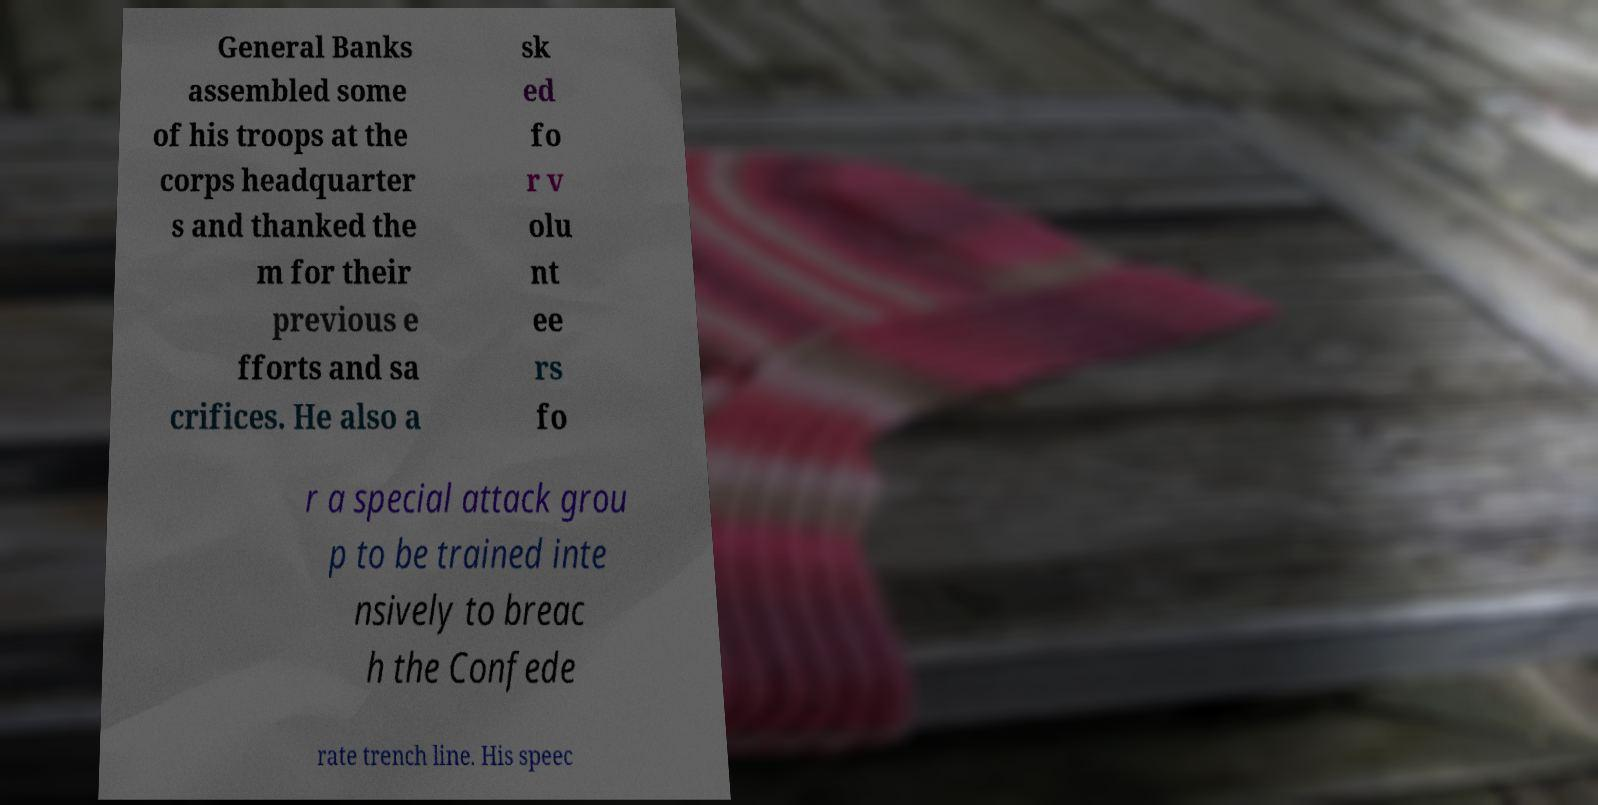I need the written content from this picture converted into text. Can you do that? General Banks assembled some of his troops at the corps headquarter s and thanked the m for their previous e fforts and sa crifices. He also a sk ed fo r v olu nt ee rs fo r a special attack grou p to be trained inte nsively to breac h the Confede rate trench line. His speec 